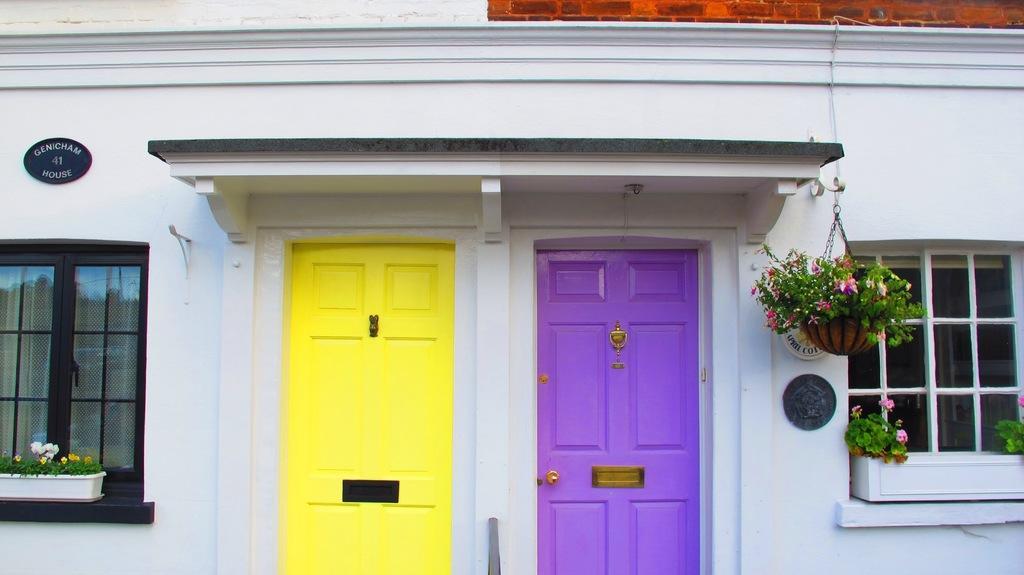Could you give a brief overview of what you see in this image? In this image I can see a building which is white in color, few windows of the building, few plants and few flowers which are white, yellow, pink and red in color. I can see two doors of the building which are yellow and purple in color. 